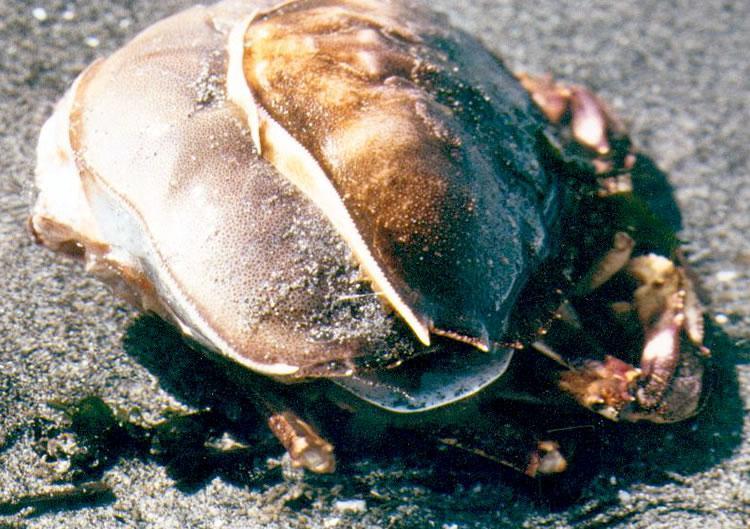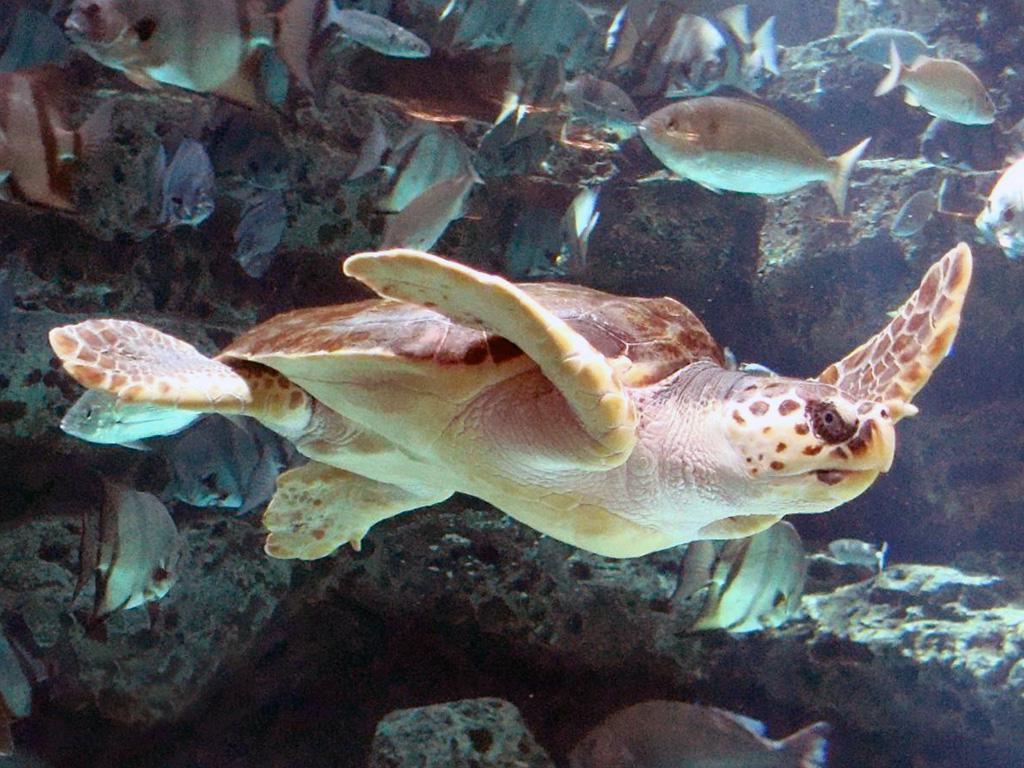The first image is the image on the left, the second image is the image on the right. Analyze the images presented: Is the assertion "At least part of an ungloved hand is seen in the left image." valid? Answer yes or no. No. The first image is the image on the left, the second image is the image on the right. Given the left and right images, does the statement "Some of the crabs are in a net." hold true? Answer yes or no. No. 